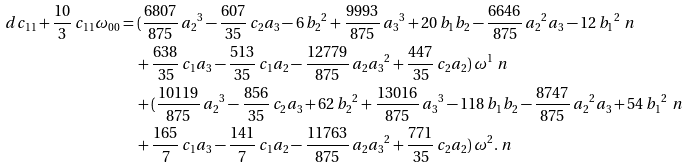<formula> <loc_0><loc_0><loc_500><loc_500>d c _ { 1 1 } + \frac { 1 0 } { 3 } \, c _ { 1 1 } \omega _ { 0 0 } & = ( { \frac { 6 8 0 7 } { 8 7 5 } } \, { a _ { 2 } } ^ { 3 } - { \frac { 6 0 7 } { 3 5 } } \, c _ { 2 } a _ { 3 } - 6 \, { b _ { 2 } } ^ { 2 } + { \frac { 9 9 9 3 } { 8 7 5 } } \, { a _ { 3 } } ^ { 3 } + 2 0 \, b _ { 1 } b _ { 2 } - { \frac { 6 6 4 6 } { 8 7 5 } } \, { a _ { 2 } } ^ { 2 } a _ { 3 } - 1 2 \, { b _ { 1 } } ^ { 2 } \ n \\ & \quad + { \frac { 6 3 8 } { 3 5 } } \, c _ { 1 } a _ { 3 } - { \frac { 5 1 3 } { 3 5 } } \, c _ { 1 } a _ { 2 } - { \frac { 1 2 7 7 9 } { 8 7 5 } } \, a _ { 2 } { a _ { 3 } } ^ { 2 } + { \frac { 4 4 7 } { 3 5 } } \, c _ { 2 } a _ { 2 } ) \, \omega ^ { 1 } \ n \\ & \quad + ( { \frac { 1 0 1 1 9 } { 8 7 5 } } \, { a _ { 2 } } ^ { 3 } - { \frac { 8 5 6 } { 3 5 } } \, c _ { 2 } a _ { 3 } + 6 2 \, { b _ { 2 } } ^ { 2 } + { \frac { 1 3 0 1 6 } { 8 7 5 } } \, { a _ { 3 } } ^ { 3 } - 1 1 8 \, b _ { 1 } b _ { 2 } - { \frac { 8 7 4 7 } { 8 7 5 } } \, { a _ { 2 } } ^ { 2 } a _ { 3 } + 5 4 \, { b _ { 1 } } ^ { 2 } \ n \\ & \quad + { \frac { 1 6 5 } { 7 } } \, c _ { 1 } a _ { 3 } - { \frac { 1 4 1 } { 7 } } \, c _ { 1 } a _ { 2 } - { \frac { 1 1 7 6 3 } { 8 7 5 } } \, a _ { 2 } { a _ { 3 } } ^ { 2 } + { \frac { 7 7 1 } { 3 5 } } \, c _ { 2 } a _ { 2 } ) \, \omega ^ { 2 } . \ n</formula> 